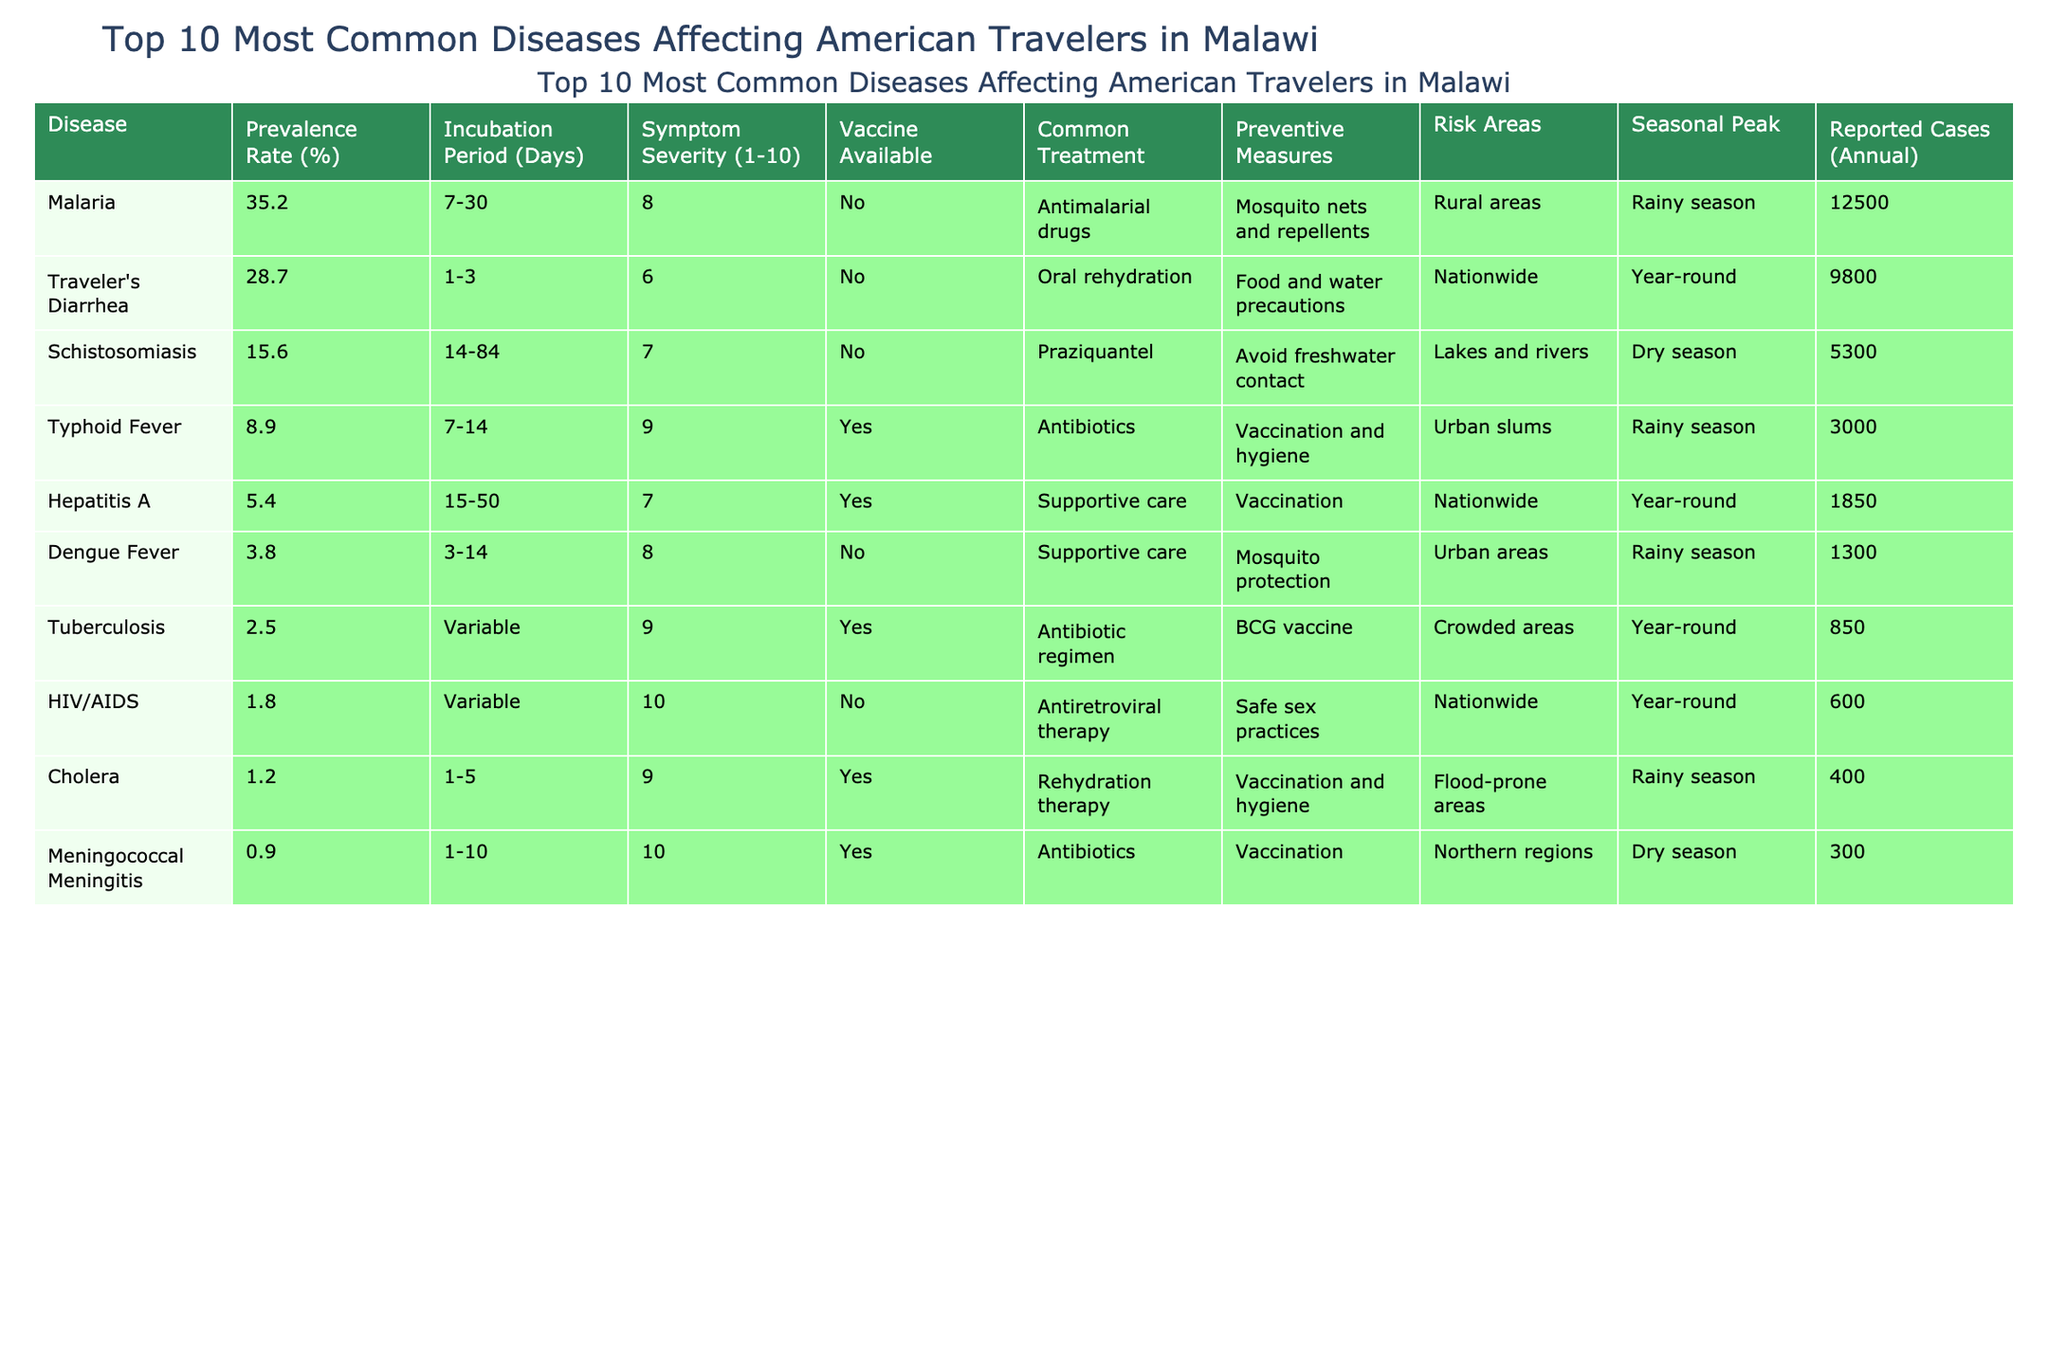What is the disease with the highest prevalence rate? Looking at the "Prevalence Rate (%)" column, Malaria has the highest rate at 35.2% among the diseases listed.
Answer: Malaria How many reported cases of Traveler's Diarrhea are there annually? Referring to the "Reported Cases (Annual)" column for Traveler's Diarrhea shows 9800 cases reported each year.
Answer: 9800 Does Hepatitis A have a vaccine available? Checking the "Vaccine Available" column, Hepatitis A is marked as having a vaccine available, indicating that a vaccination exists for this disease.
Answer: Yes What is the average incubation period for diseases in this table? To find the average incubation period, convert the ranges to estimates: Malaria (18.5), Traveler's Diarrhea (2), Schistosomiasis (49), Typhoid Fever (10.5), Hepatitis A (32.5), Dengue Fever (8.5), Tuberculosis (not calculable, counted as variable), HIV/AIDS (variable), Cholera (3), and Meningococcal Meningitis (5.5). Then sum the calculable ones (18.5 + 2 + 49 + 10.5 + 32.5 + 8.5 + 3 + 5.5) and divide by 8, resulting in an average of approximately 12.5 days.
Answer: 12.5 Which disease has the lowest prevalence rate? From the "Prevalence Rate (%)" column, Meningococcal Meningitis shows the lowest rate at 0.9% among the listed diseases.
Answer: Meningococcal Meningitis What factor increases the risk of contracting Cholera? According to the "Risk Areas" column, Cholera is most common in flood-prone areas, indicating that living or traveling in such conditions elevates the risk of infection.
Answer: Flood-prone areas What is the symptom severity score for Tuberculosis? Checking the "Symptom Severity (1-10)" column, Tuberculosis has a severity score of 9, indicating a high severity of symptoms associated with this disease.
Answer: 9 How many diseases have a seasonal peak during the rainy season? By reviewing the "Seasonal Peak" column, Malaria, Traveler's Diarrhea, Typhoid Fever, Dengue Fever, and Cholera all show a peak in the rainy season. This amounts to a total of 5 diseases.
Answer: 5 Which diseases can be prevented through vaccination? In the "Vaccine Available" column, Typhoid Fever, Hepatitis A, Cholera, and Meningococcal Meningitis all have vaccines available, indicating that there are four diseases that can be prevented via vaccination.
Answer: 4 What is the incidence of dengue fever compared to travelers' diarrhea? Referring to the "Reported Cases (Annual)" column, Traveler's Diarrhea has 9800 reported cases, while Dengue Fever has 1300 cases. When comparing, Traveler's Diarrhea has significantly more cases (9800 - 1300 = 8500 more).
Answer: 8500 more cases Is Schistosomiasis reported more often in the dry season than in the rainy season? Looking at the "Seasonal Peak" column, Schistosomiasis peaks in the dry season, while most other diseases peak in the rainy season; therefore, it is only compared with its own seasonal pattern. Since no other diseases peak in the dry season, the implication is that it is relatively more common during its peak season compared to the overall rainy season cases.
Answer: Yes 